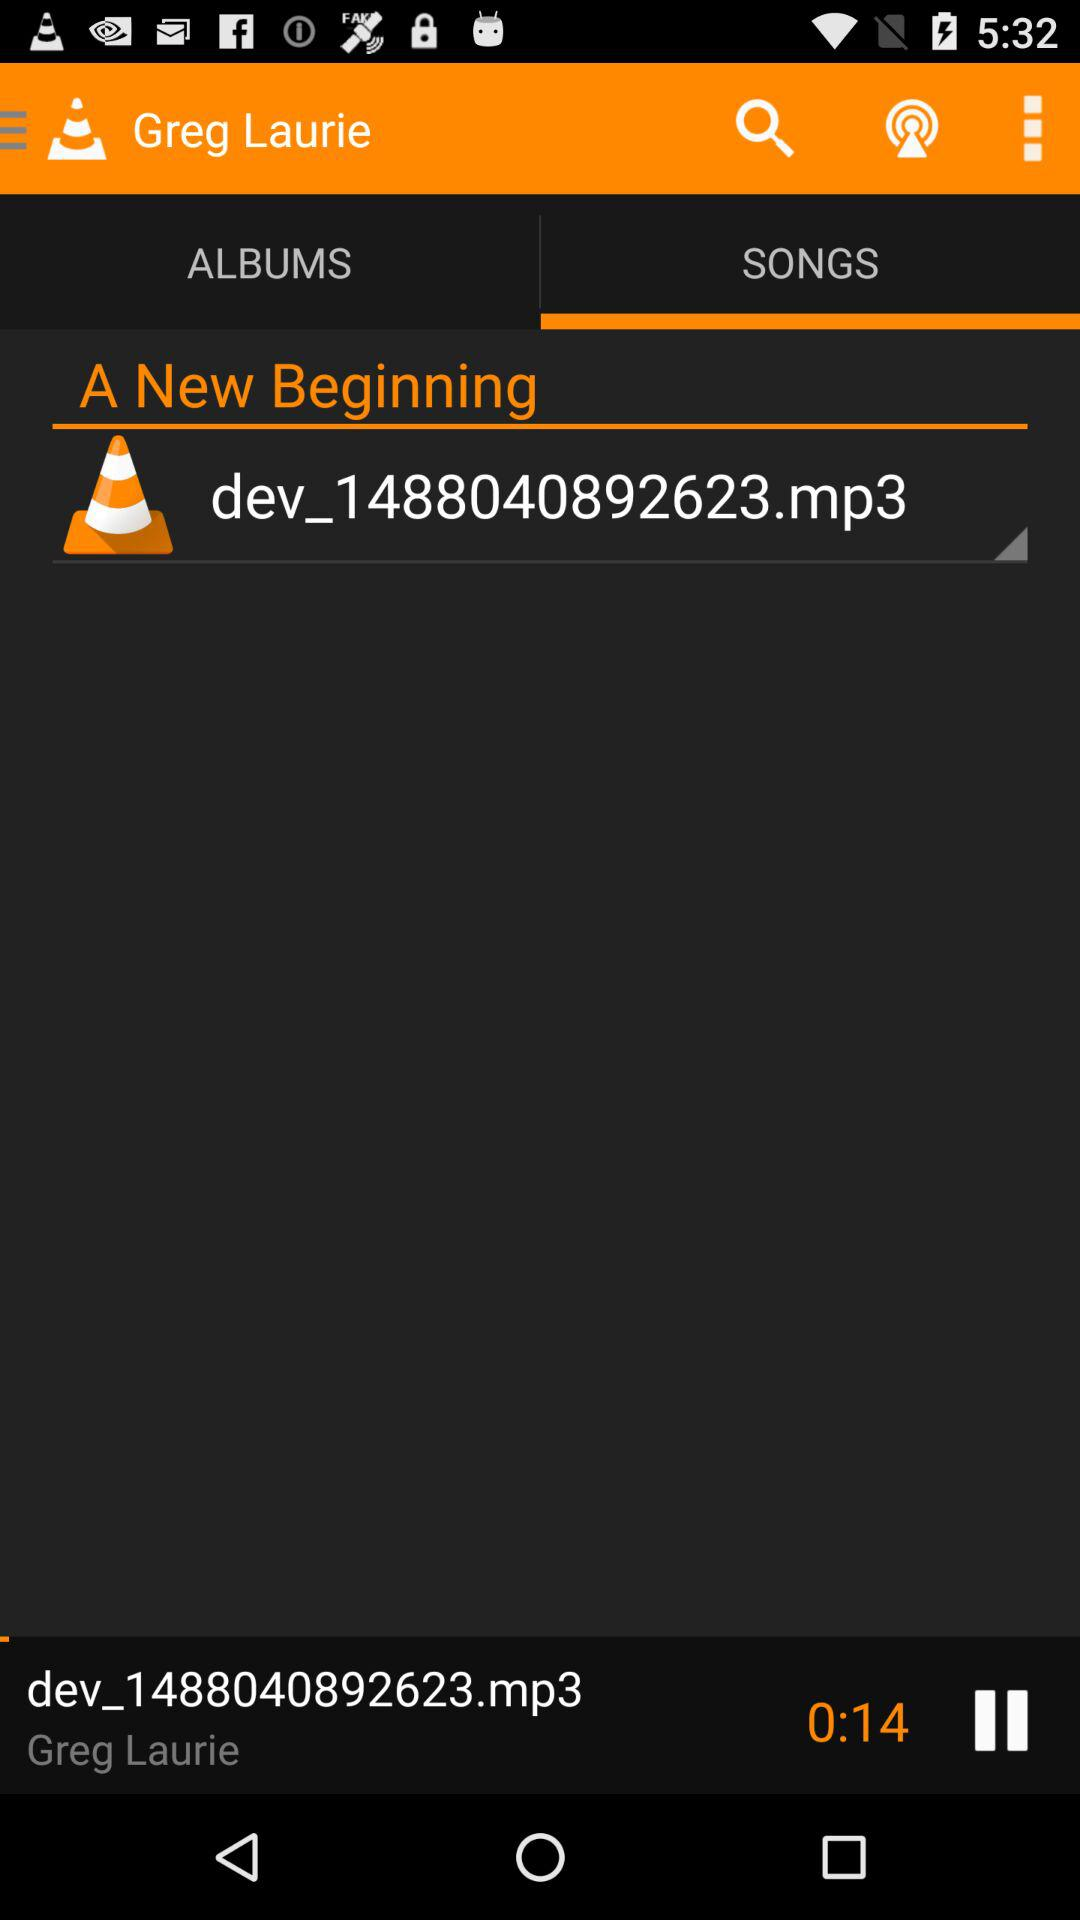How long is the song?
Answer the question using a single word or phrase. 0:14 